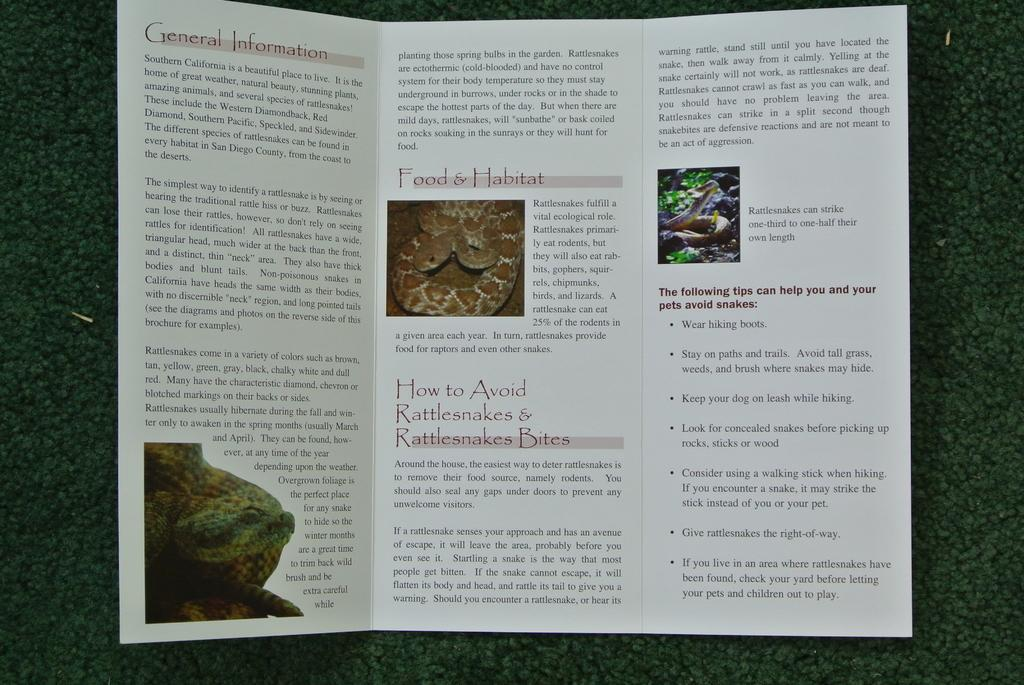What is the main object in the image? There is a card in the image. What is the color of the surface the card is placed on? The card is placed on a green surface. What type of content is on the card? The card contains information and images. What song is playing in the background of the image? There is no information about a song playing in the background of the image. 